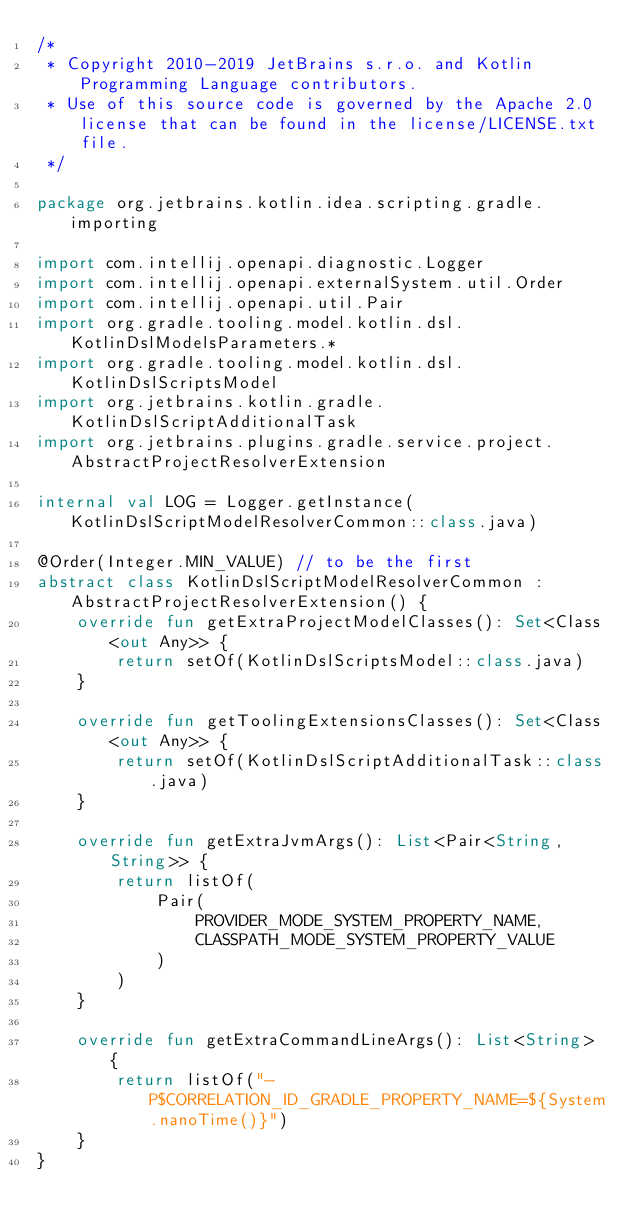Convert code to text. <code><loc_0><loc_0><loc_500><loc_500><_Kotlin_>/*
 * Copyright 2010-2019 JetBrains s.r.o. and Kotlin Programming Language contributors.
 * Use of this source code is governed by the Apache 2.0 license that can be found in the license/LICENSE.txt file.
 */

package org.jetbrains.kotlin.idea.scripting.gradle.importing

import com.intellij.openapi.diagnostic.Logger
import com.intellij.openapi.externalSystem.util.Order
import com.intellij.openapi.util.Pair
import org.gradle.tooling.model.kotlin.dsl.KotlinDslModelsParameters.*
import org.gradle.tooling.model.kotlin.dsl.KotlinDslScriptsModel
import org.jetbrains.kotlin.gradle.KotlinDslScriptAdditionalTask
import org.jetbrains.plugins.gradle.service.project.AbstractProjectResolverExtension

internal val LOG = Logger.getInstance(KotlinDslScriptModelResolverCommon::class.java)

@Order(Integer.MIN_VALUE) // to be the first
abstract class KotlinDslScriptModelResolverCommon : AbstractProjectResolverExtension() {
    override fun getExtraProjectModelClasses(): Set<Class<out Any>> {
        return setOf(KotlinDslScriptsModel::class.java)
    }

    override fun getToolingExtensionsClasses(): Set<Class<out Any>> {
        return setOf(KotlinDslScriptAdditionalTask::class.java)
    }

    override fun getExtraJvmArgs(): List<Pair<String, String>> {
        return listOf(
            Pair(
                PROVIDER_MODE_SYSTEM_PROPERTY_NAME,
                CLASSPATH_MODE_SYSTEM_PROPERTY_VALUE
            )
        )
    }

    override fun getExtraCommandLineArgs(): List<String> {
        return listOf("-P$CORRELATION_ID_GRADLE_PROPERTY_NAME=${System.nanoTime()}")
    }
}</code> 